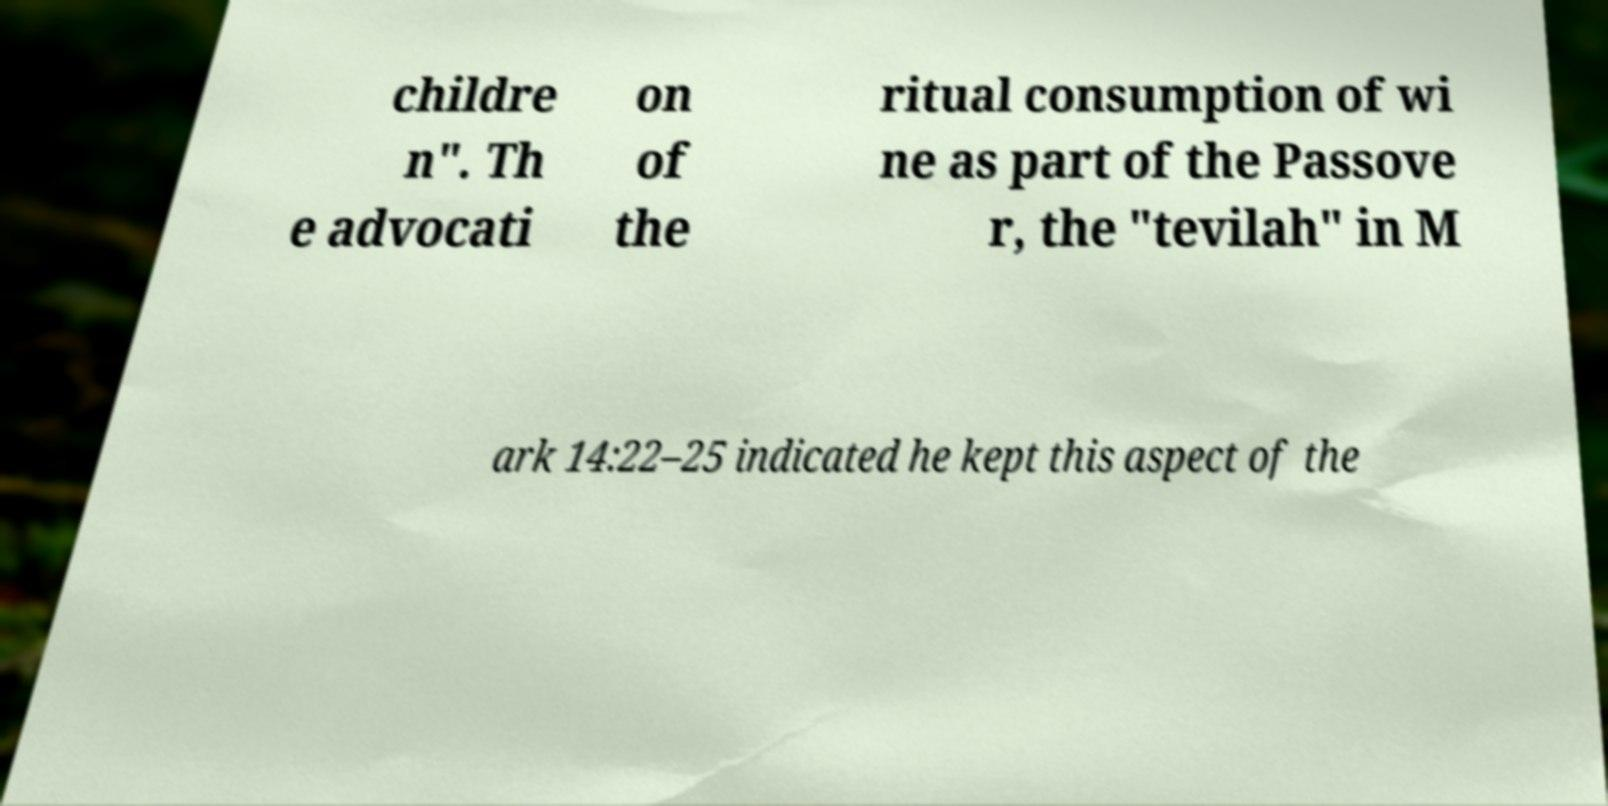For documentation purposes, I need the text within this image transcribed. Could you provide that? childre n". Th e advocati on of the ritual consumption of wi ne as part of the Passove r, the "tevilah" in M ark 14:22–25 indicated he kept this aspect of the 